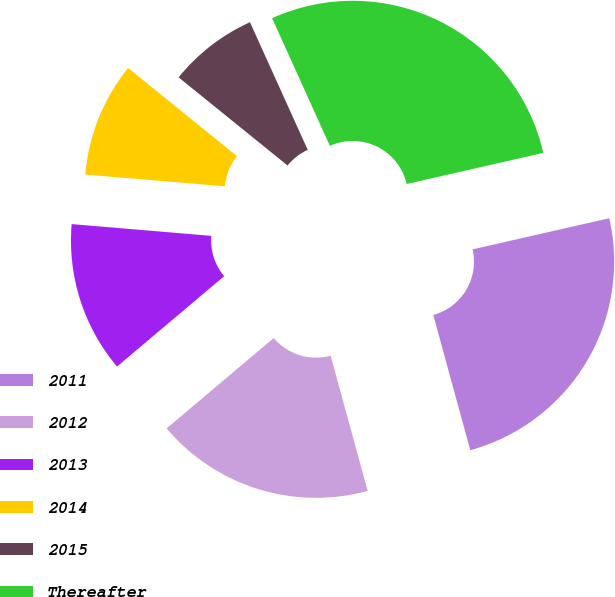<chart> <loc_0><loc_0><loc_500><loc_500><pie_chart><fcel>2011<fcel>2012<fcel>2013<fcel>2014<fcel>2015<fcel>Thereafter<nl><fcel>24.31%<fcel>18.1%<fcel>12.49%<fcel>9.49%<fcel>7.41%<fcel>28.2%<nl></chart> 